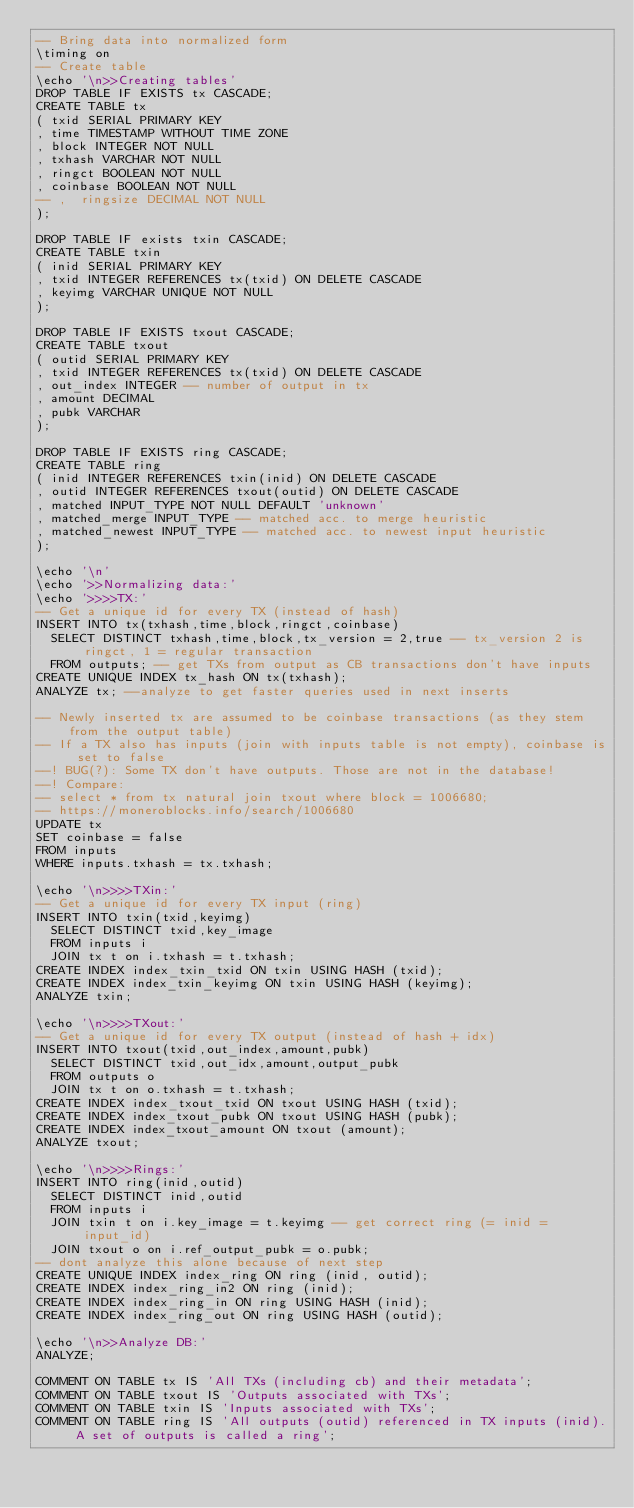<code> <loc_0><loc_0><loc_500><loc_500><_SQL_>-- Bring data into normalized form
\timing on
-- Create table
\echo '\n>>Creating tables'
DROP TABLE IF EXISTS tx CASCADE;
CREATE TABLE tx
(	txid SERIAL PRIMARY KEY
,	time TIMESTAMP WITHOUT TIME ZONE
,	block INTEGER NOT NULL
,	txhash VARCHAR NOT NULL
,	ringct BOOLEAN NOT NULL
,	coinbase BOOLEAN NOT NULL
-- ,	ringsize DECIMAL NOT NULL
);

DROP TABLE IF exists txin CASCADE;
CREATE TABLE txin
(	inid SERIAL PRIMARY KEY
,	txid INTEGER REFERENCES tx(txid) ON DELETE CASCADE
,	keyimg VARCHAR UNIQUE NOT NULL
);

DROP TABLE IF EXISTS txout CASCADE;
CREATE TABLE txout
(	outid SERIAL PRIMARY KEY
,	txid INTEGER REFERENCES tx(txid) ON DELETE CASCADE
,	out_index INTEGER -- number of output in tx
,	amount DECIMAL
,	pubk VARCHAR
);

DROP TABLE IF EXISTS ring CASCADE;
CREATE TABLE ring
(	inid INTEGER REFERENCES txin(inid) ON DELETE CASCADE 
,	outid INTEGER REFERENCES txout(outid) ON DELETE CASCADE
,	matched INPUT_TYPE NOT NULL DEFAULT 'unknown'
,	matched_merge INPUT_TYPE -- matched acc. to merge heuristic
,	matched_newest INPUT_TYPE -- matched acc. to newest input heuristic
);

\echo '\n'
\echo '>>Normalizing data:'
\echo '>>>>TX:'
-- Get a unique id for every TX (instead of hash)
INSERT INTO tx(txhash,time,block,ringct,coinbase)
	SELECT DISTINCT txhash,time,block,tx_version = 2,true -- tx_version 2 is ringct, 1 = regular transaction
	FROM outputs; -- get TXs from output as CB transactions don't have inputs
CREATE UNIQUE INDEX tx_hash ON tx(txhash);
ANALYZE tx; --analyze to get faster queries used in next inserts

-- Newly inserted tx are assumed to be coinbase transactions (as they stem from the output table)
-- If a TX also has inputs (join with inputs table is not empty), coinbase is set to false
--! BUG(?): Some TX don't have outputs. Those are not in the database!
--! Compare:
-- select * from tx natural join txout where block = 1006680;
-- https://moneroblocks.info/search/1006680
UPDATE tx 
SET coinbase = false
FROM inputs
WHERE inputs.txhash = tx.txhash;

\echo '\n>>>>TXin:'
-- Get a unique id for every TX input (ring)
INSERT INTO txin(txid,keyimg)
	SELECT DISTINCT txid,key_image
	FROM inputs i
	JOIN tx t on i.txhash = t.txhash;
CREATE INDEX index_txin_txid ON txin USING HASH (txid);
CREATE INDEX index_txin_keyimg ON txin USING HASH (keyimg);
ANALYZE txin;

\echo '\n>>>>TXout:'
-- Get a unique id for every TX output (instead of hash + idx)
INSERT INTO txout(txid,out_index,amount,pubk)
	SELECT DISTINCT txid,out_idx,amount,output_pubk
	FROM outputs o
	JOIN tx t on o.txhash = t.txhash;
CREATE INDEX index_txout_txid ON txout USING HASH (txid);
CREATE INDEX index_txout_pubk ON txout USING HASH (pubk);
CREATE INDEX index_txout_amount ON txout (amount);
ANALYZE txout;

\echo '\n>>>>Rings:'
INSERT INTO ring(inid,outid)
	SELECT DISTINCT inid,outid
	FROM inputs i
	JOIN txin t on i.key_image = t.keyimg -- get correct ring (= inid = input_id)
	JOIN txout o on i.ref_output_pubk = o.pubk;
-- dont analyze this alone because of next step
CREATE UNIQUE INDEX index_ring ON ring (inid, outid);
CREATE INDEX index_ring_in2 ON ring (inid);
CREATE INDEX index_ring_in ON ring USING HASH (inid);
CREATE INDEX index_ring_out ON ring USING HASH (outid);

\echo '\n>>Analyze DB:'
ANALYZE;

COMMENT ON TABLE tx IS 'All TXs (including cb) and their metadata';
COMMENT ON TABLE txout IS 'Outputs associated with TXs';
COMMENT ON TABLE txin IS 'Inputs associated with TXs';
COMMENT ON TABLE ring IS 'All outputs (outid) referenced in TX inputs (inid). A set of outputs is called a ring';</code> 